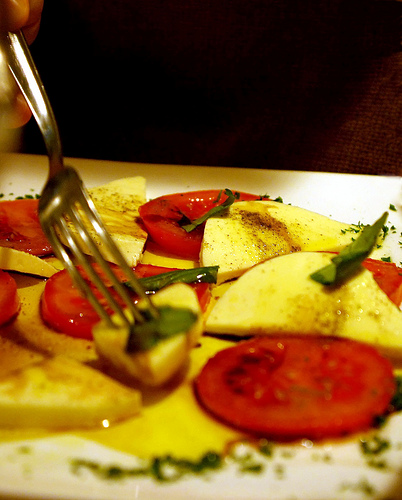<image>
Can you confirm if the squash is to the left of the chive? Yes. From this viewpoint, the squash is positioned to the left side relative to the chive. 